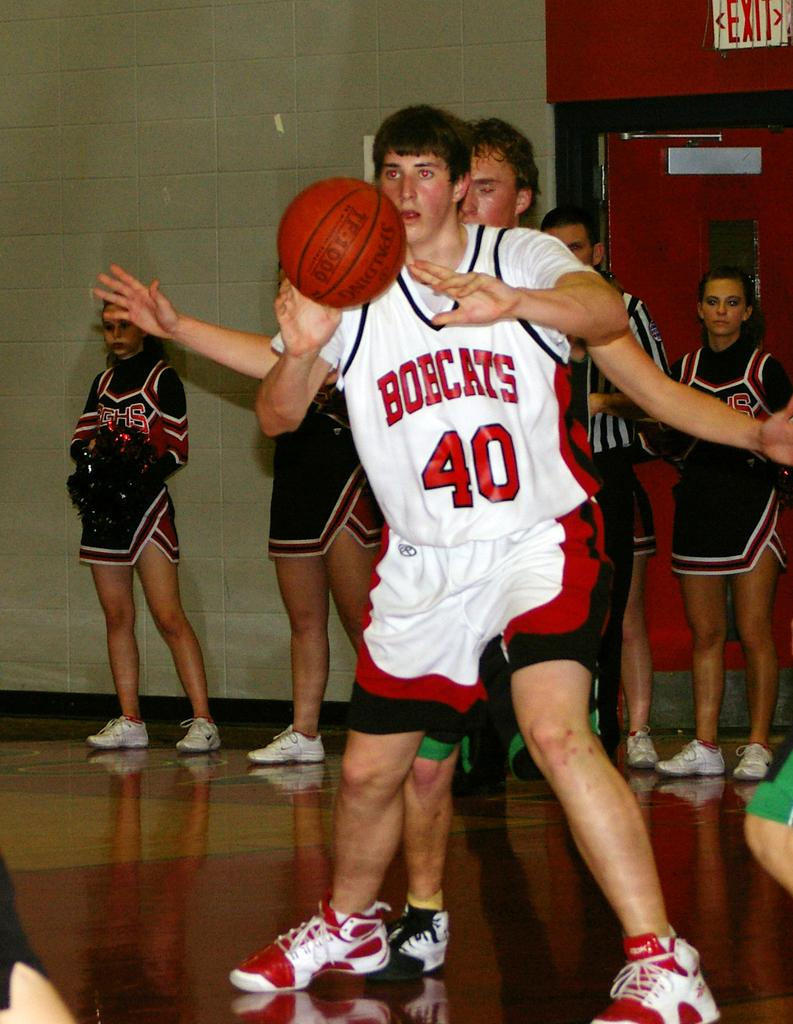<image>
Present a compact description of the photo's key features. An athlete in a white jersey with the number 40 on it. 